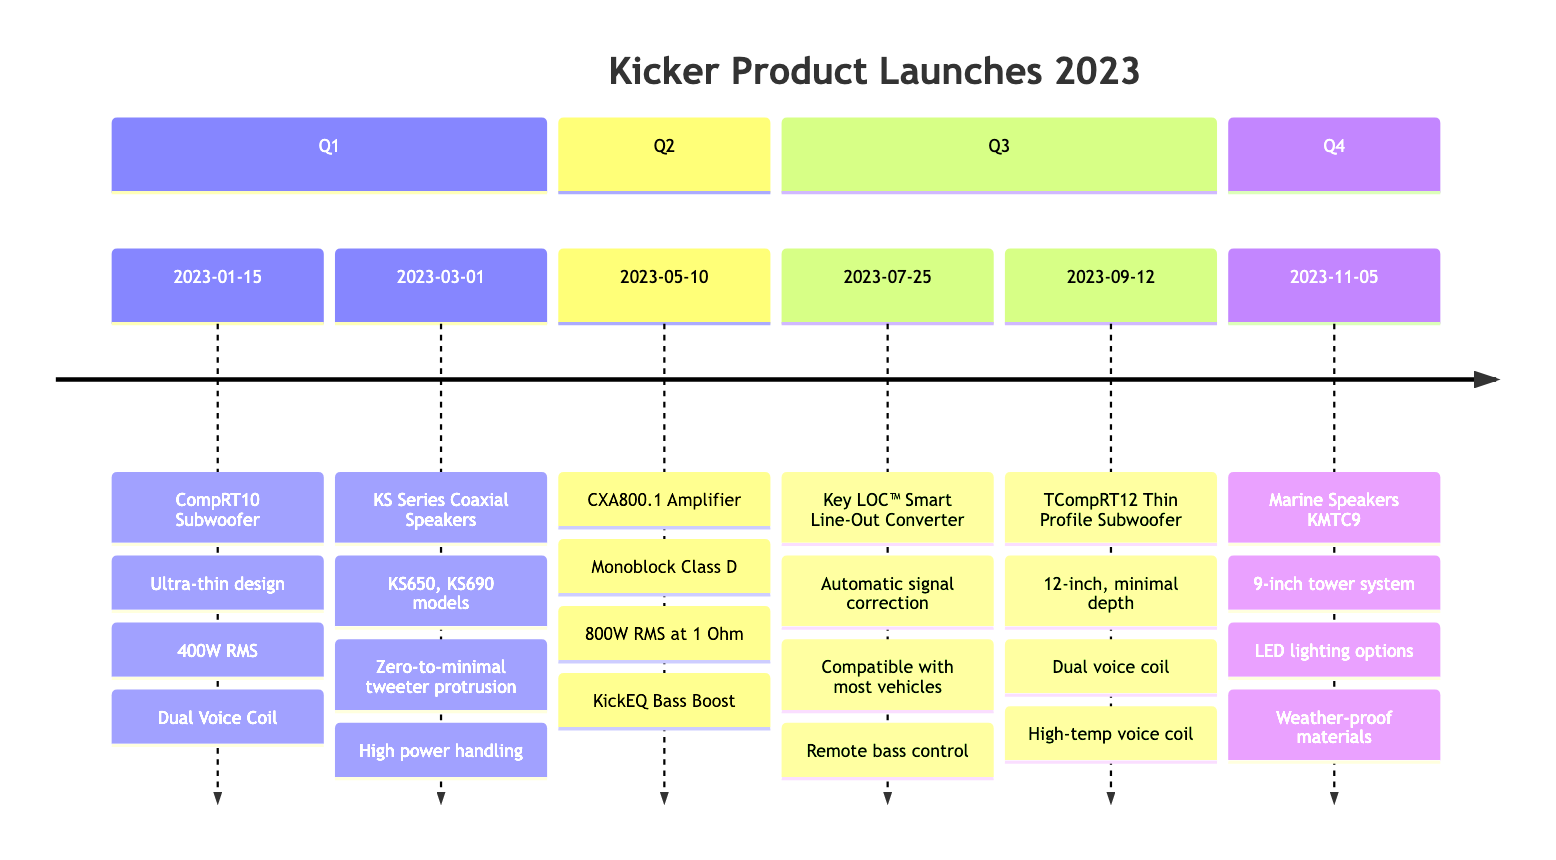What product was launched on January 15, 2023? The diagram indicates the product launched on this date is the Kicker CompRT10 Subwoofer.
Answer: Kicker CompRT10 Subwoofer How many products were launched in Q2? In the "Q2" section of the timeline, there is one product listed: the Kicker CXA800.1 Amplifier, which means only one product was launched in this quarter.
Answer: 1 What is the power handling of the Kicker CXA800.1 Amplifier? The timeline specifies that the Kicker CXA800.1 Amplifier has a power handling of 800 Watts RMS at 1 Ohm.
Answer: 800 Watts RMS Which subwoofer was introduced after the Kicker CompRT10? According to the timeline, the Kicker KS Series Coaxial Speakers were introduced after the Kicker CompRT10 Subwoofer, making it the subsequent product launch.
Answer: Kicker KS Series Coaxial Speakers What feature do the Kicker Marine Speakers KMTC9 have for outdoor use? The timeline mentions that the Kicker Marine Speakers KMTC9 are constructed with weather-proof materials, making them suitable for outdoor environments.
Answer: Weather-proof materials What is the launch date for the TCompRT12 Thin Profile Subwoofer? The timeline indicates that the TCompRT12 Thin Profile Subwoofer was launched on September 12, 2023.
Answer: September 12, 2023 How many features are listed for the Kicker Key LOC™ Smart Line-Out Converter? The diagram details three features for the Kicker Key LOC™ Smart Line-Out Converter, which are automatic signal correction, compatibility with nearly all vehicles, and remote bass control.
Answer: 3 Which model series of speakers was introduced in March? The timeline shows that the Kicker KS Series Coaxial Speakers were introduced in March.
Answer: Kicker KS Series Coaxial Speakers What does the CXA800.1 Amplifier specialize in? The timeline describes the CXA800.1 Amplifier as a monoblock Class D amplifier, indicating its specialization in high-power output for subwoofer systems.
Answer: Monoblock Class D amplifier 